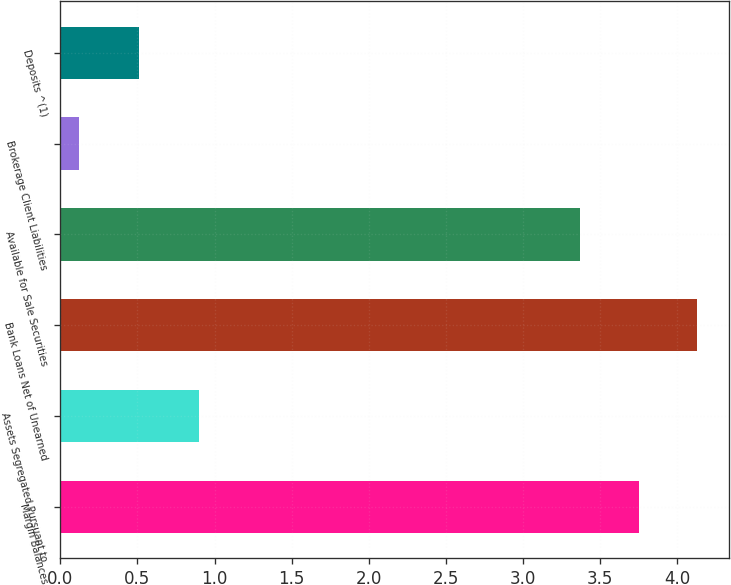Convert chart to OTSL. <chart><loc_0><loc_0><loc_500><loc_500><bar_chart><fcel>Margin Balances<fcel>Assets Segregated Pursuant to<fcel>Bank Loans Net of Unearned<fcel>Available for Sale Securities<fcel>Brokerage Client Liabilities<fcel>Deposits ^(1)<nl><fcel>3.75<fcel>0.9<fcel>4.13<fcel>3.37<fcel>0.12<fcel>0.51<nl></chart> 